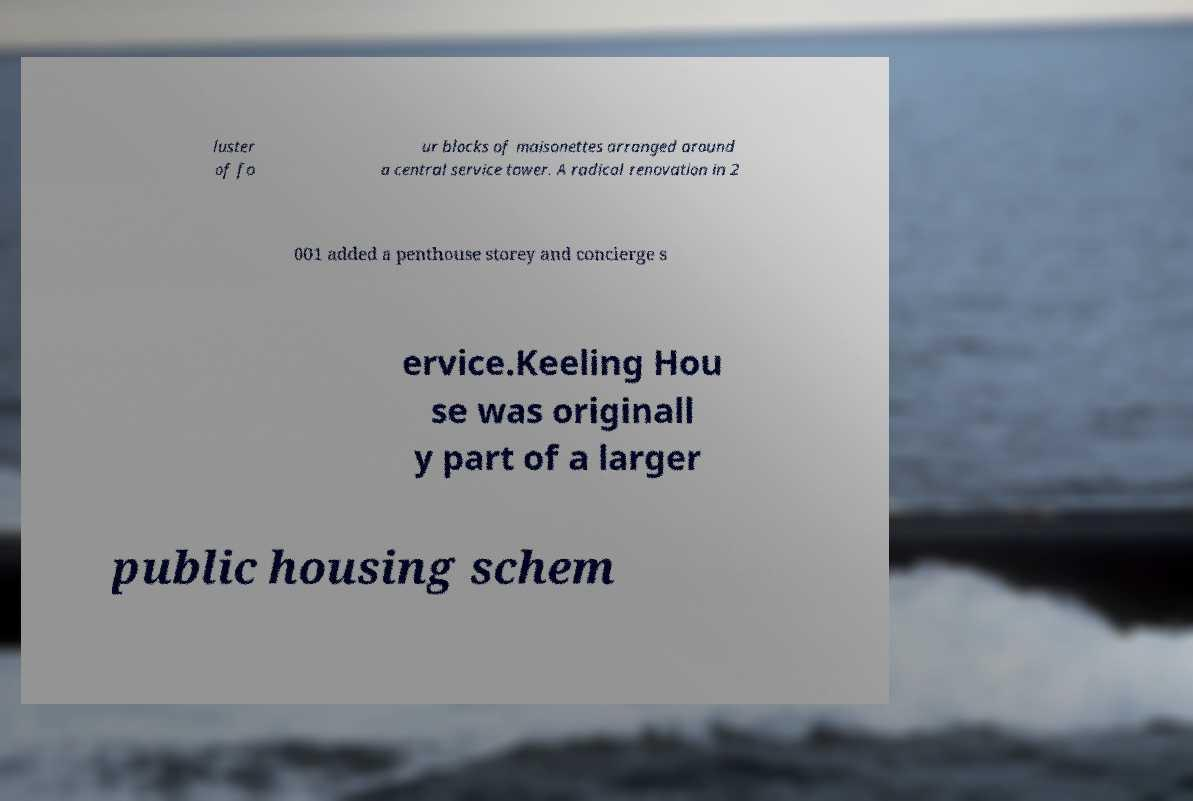Could you assist in decoding the text presented in this image and type it out clearly? luster of fo ur blocks of maisonettes arranged around a central service tower. A radical renovation in 2 001 added a penthouse storey and concierge s ervice.Keeling Hou se was originall y part of a larger public housing schem 